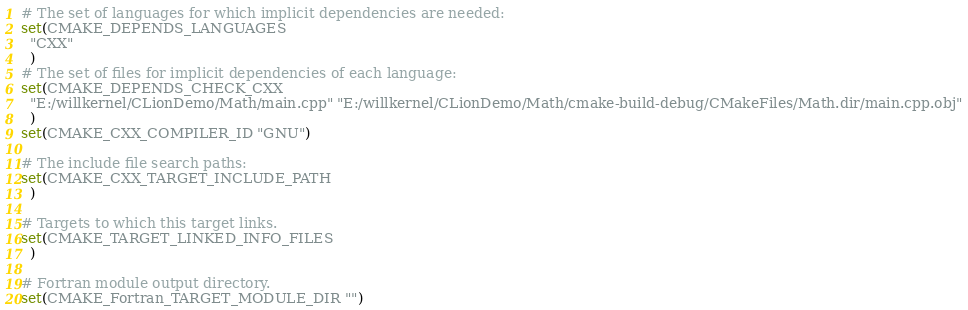<code> <loc_0><loc_0><loc_500><loc_500><_CMake_># The set of languages for which implicit dependencies are needed:
set(CMAKE_DEPENDS_LANGUAGES
  "CXX"
  )
# The set of files for implicit dependencies of each language:
set(CMAKE_DEPENDS_CHECK_CXX
  "E:/willkernel/CLionDemo/Math/main.cpp" "E:/willkernel/CLionDemo/Math/cmake-build-debug/CMakeFiles/Math.dir/main.cpp.obj"
  )
set(CMAKE_CXX_COMPILER_ID "GNU")

# The include file search paths:
set(CMAKE_CXX_TARGET_INCLUDE_PATH
  )

# Targets to which this target links.
set(CMAKE_TARGET_LINKED_INFO_FILES
  )

# Fortran module output directory.
set(CMAKE_Fortran_TARGET_MODULE_DIR "")
</code> 